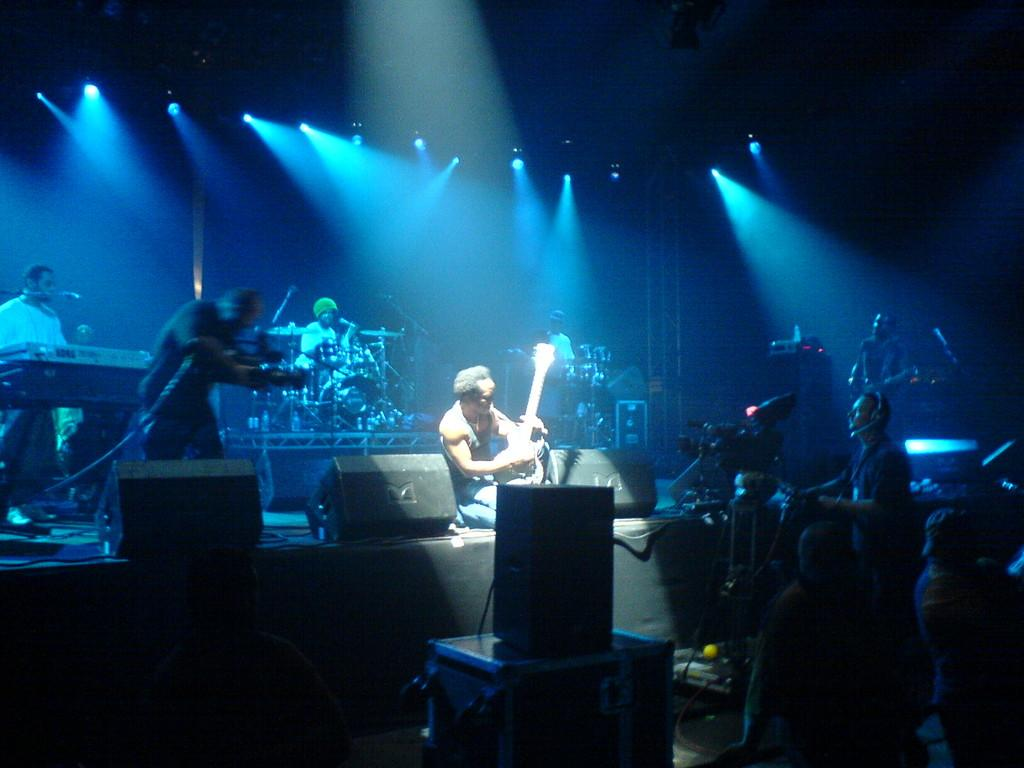What type of performance is taking place in the image? There is a rock band performing in the image. Can you describe the position of the guitarist in the band? A person with a guitar is in the front of the band. Who else is present at the event besides the band members? There is a cameraman present at the event. What type of rake is being used by the band to create their music? There is no rake present in the image; the band is using musical instruments to perform. 